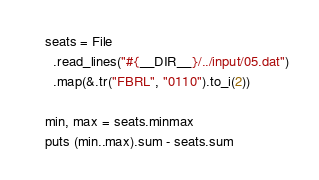<code> <loc_0><loc_0><loc_500><loc_500><_Crystal_>seats = File
  .read_lines("#{__DIR__}/../input/05.dat")
  .map(&.tr("FBRL", "0110").to_i(2))

min, max = seats.minmax
puts (min..max).sum - seats.sum
</code> 